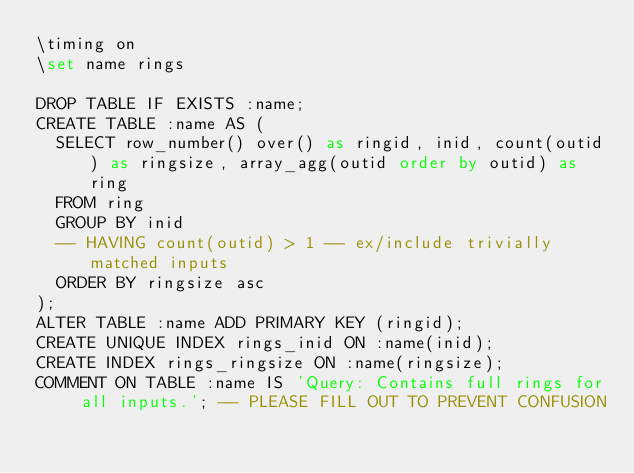<code> <loc_0><loc_0><loc_500><loc_500><_SQL_>\timing on
\set name rings

DROP TABLE IF EXISTS :name;
CREATE TABLE :name AS (
	SELECT row_number() over() as ringid, inid, count(outid) as ringsize, array_agg(outid order by outid) as ring
	FROM ring
	GROUP BY inid
	-- HAVING count(outid) > 1 -- ex/include trivially matched inputs
	ORDER BY ringsize asc
);
ALTER TABLE :name ADD PRIMARY KEY (ringid);
CREATE UNIQUE INDEX rings_inid ON :name(inid);
CREATE INDEX rings_ringsize ON :name(ringsize);
COMMENT ON TABLE :name IS 'Query: Contains full rings for all inputs.'; -- PLEASE FILL OUT TO PREVENT CONFUSION</code> 